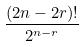<formula> <loc_0><loc_0><loc_500><loc_500>\frac { ( 2 n - 2 r ) ! } { 2 ^ { n - r } }</formula> 